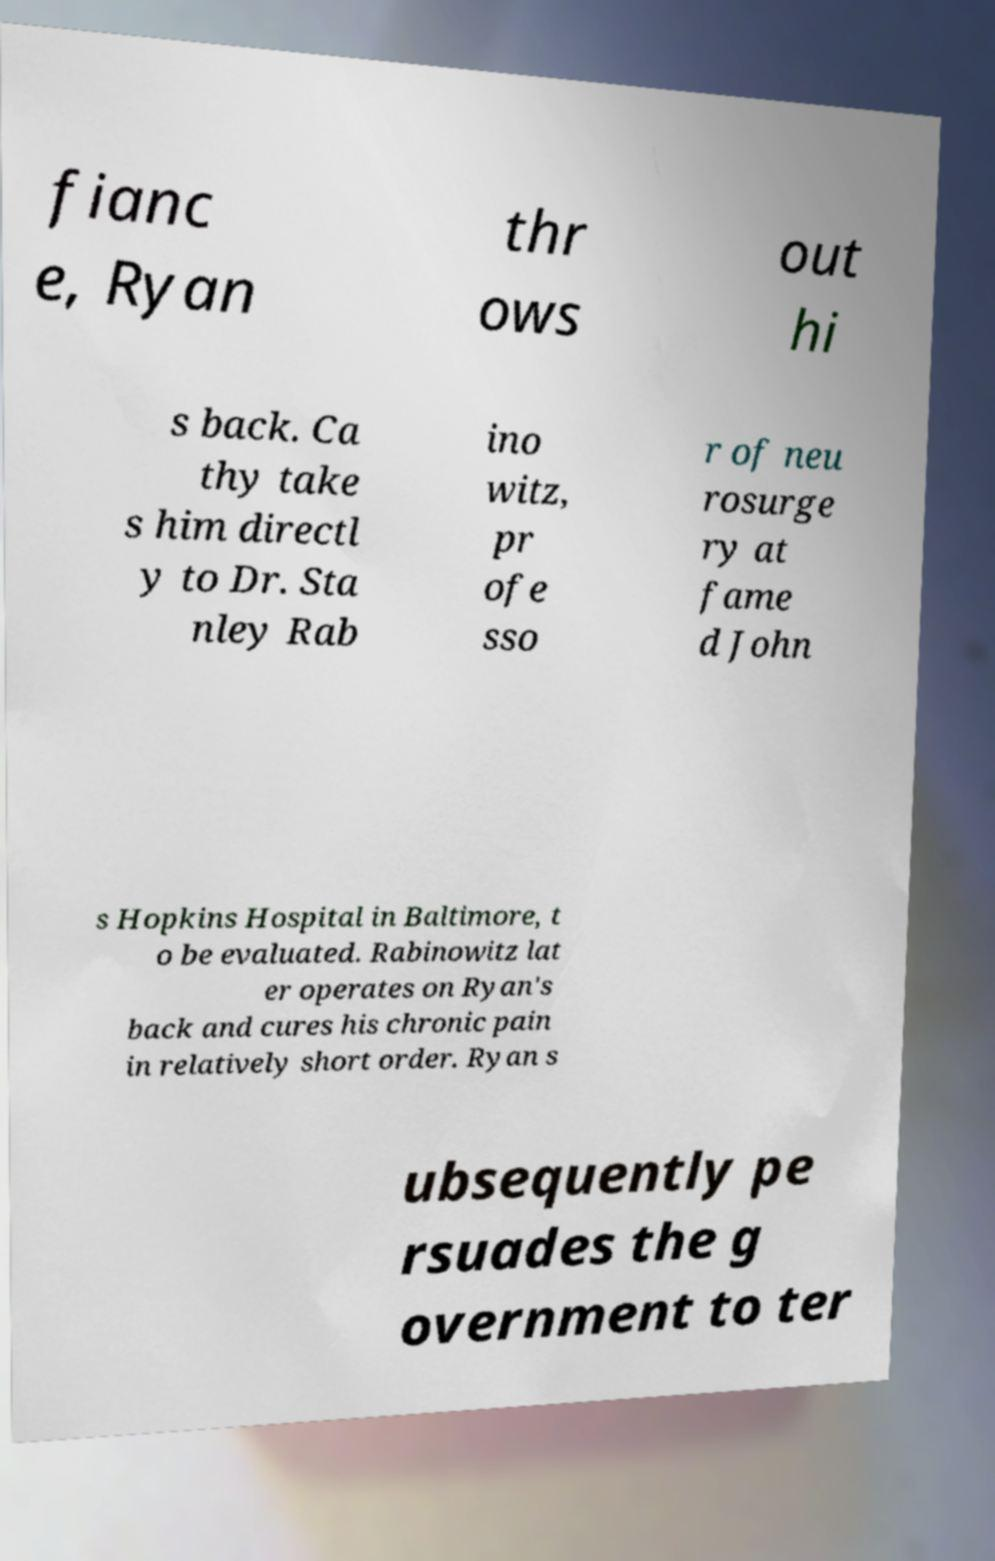There's text embedded in this image that I need extracted. Can you transcribe it verbatim? fianc e, Ryan thr ows out hi s back. Ca thy take s him directl y to Dr. Sta nley Rab ino witz, pr ofe sso r of neu rosurge ry at fame d John s Hopkins Hospital in Baltimore, t o be evaluated. Rabinowitz lat er operates on Ryan's back and cures his chronic pain in relatively short order. Ryan s ubsequently pe rsuades the g overnment to ter 